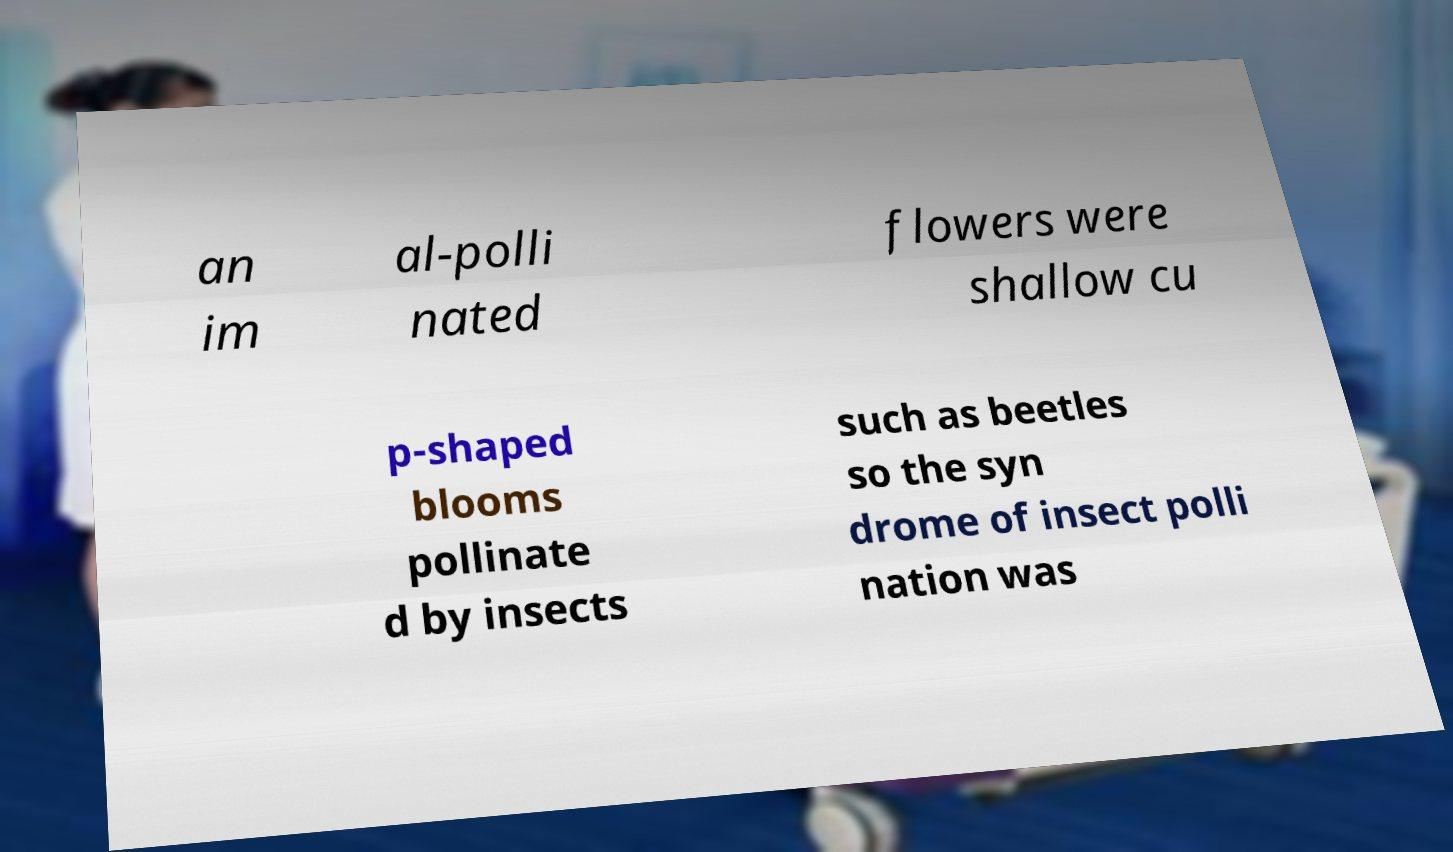There's text embedded in this image that I need extracted. Can you transcribe it verbatim? an im al-polli nated flowers were shallow cu p-shaped blooms pollinate d by insects such as beetles so the syn drome of insect polli nation was 